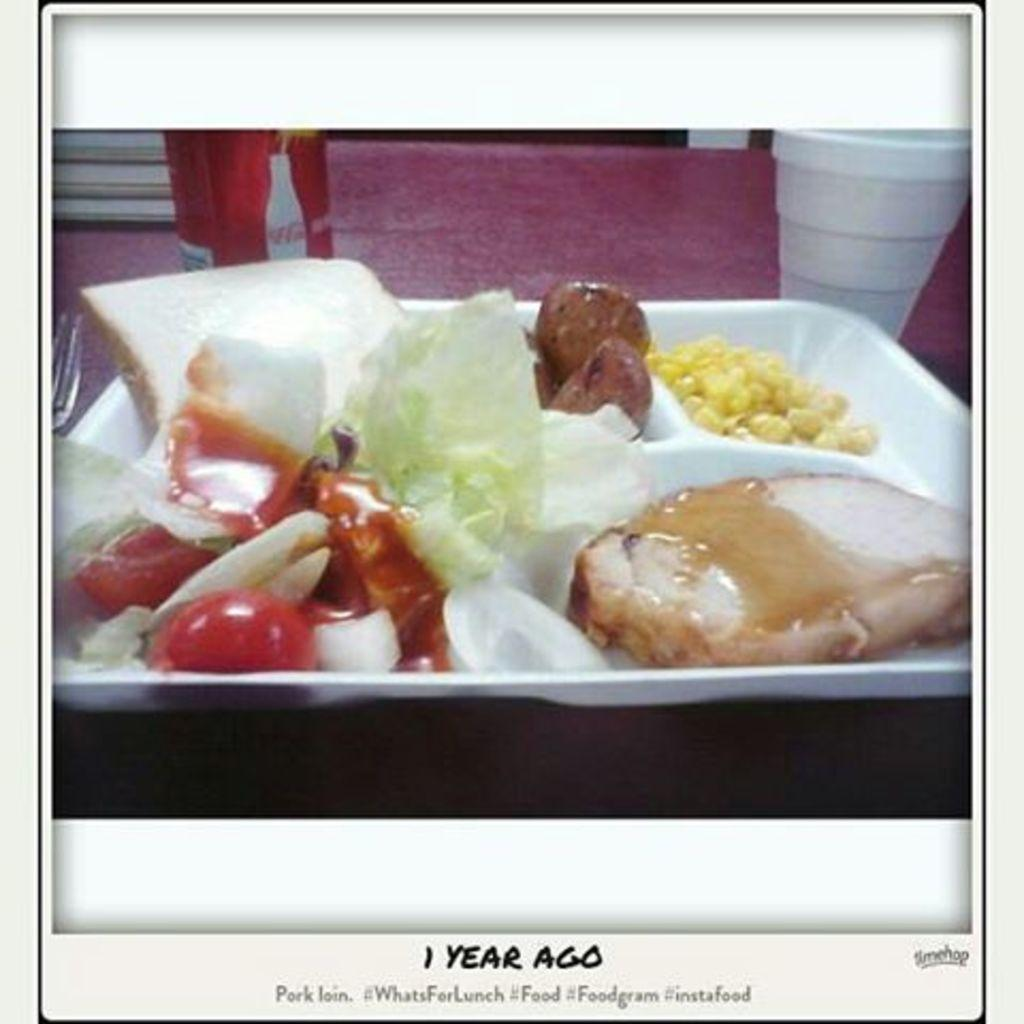What is on the plate in the image? There are food items on a plate in the image. What is located beside the plate? There is a tin beside the plate. What can be found on the table in the image? There is a cup and a fork on the table. Is there any text visible in the image? Yes, there is some text at the bottom of the image. What type of needle is being used to stir the paste in the image? There is no needle or paste present in the image. 